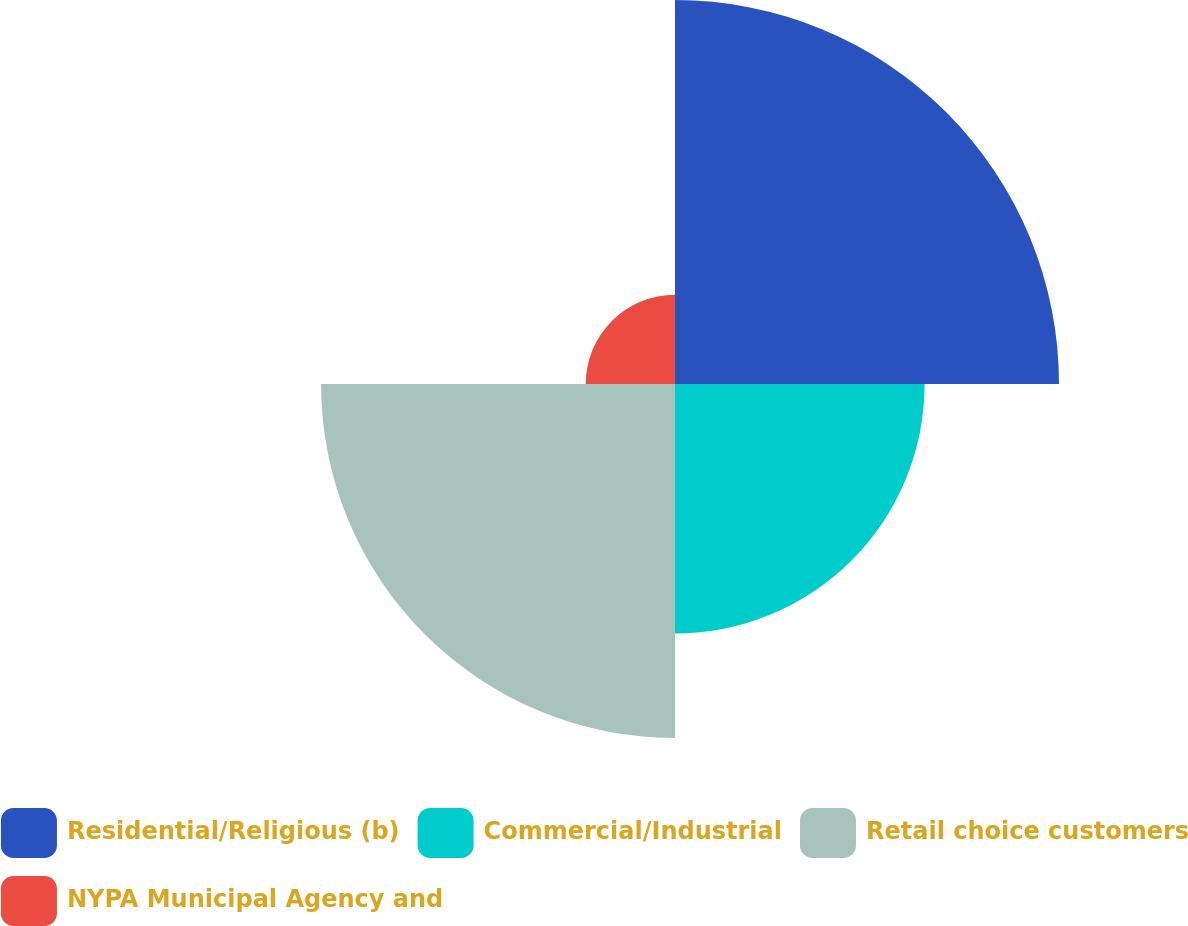<chart> <loc_0><loc_0><loc_500><loc_500><pie_chart><fcel>Residential/Religious (b)<fcel>Commercial/Industrial<fcel>Retail choice customers<fcel>NYPA Municipal Agency and<nl><fcel>35.66%<fcel>23.18%<fcel>32.87%<fcel>8.29%<nl></chart> 